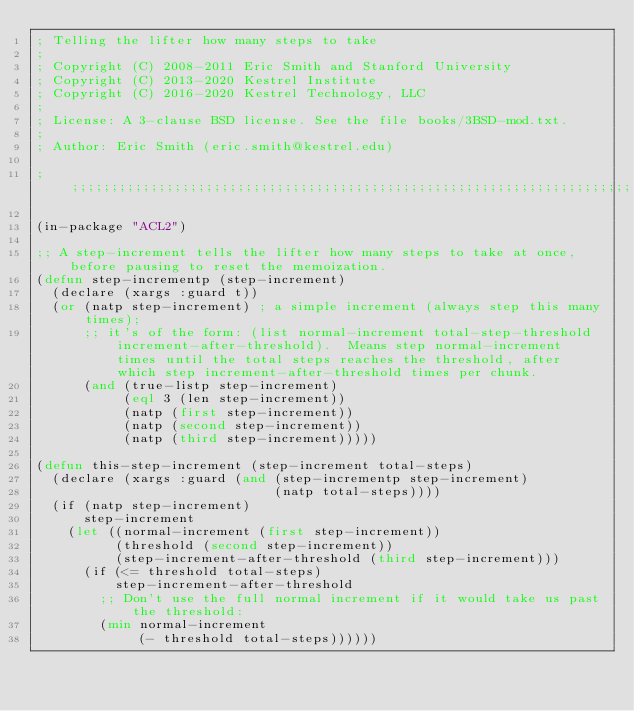<code> <loc_0><loc_0><loc_500><loc_500><_Lisp_>; Telling the lifter how many steps to take
;
; Copyright (C) 2008-2011 Eric Smith and Stanford University
; Copyright (C) 2013-2020 Kestrel Institute
; Copyright (C) 2016-2020 Kestrel Technology, LLC
;
; License: A 3-clause BSD license. See the file books/3BSD-mod.txt.
;
; Author: Eric Smith (eric.smith@kestrel.edu)

;;;;;;;;;;;;;;;;;;;;;;;;;;;;;;;;;;;;;;;;;;;;;;;;;;;;;;;;;;;;;;;;;;;;;;;;;;;;;;;;

(in-package "ACL2")

;; A step-increment tells the lifter how many steps to take at once, before pausing to reset the memoization.
(defun step-incrementp (step-increment)
  (declare (xargs :guard t))
  (or (natp step-increment) ; a simple increment (always step this many times);
      ;; it's of the form: (list normal-increment total-step-threshold increment-after-threshold).  Means step normal-increment times until the total steps reaches the threshold, after which step increment-after-threshold times per chunk.
      (and (true-listp step-increment)
           (eql 3 (len step-increment))
           (natp (first step-increment))
           (natp (second step-increment))
           (natp (third step-increment)))))

(defun this-step-increment (step-increment total-steps)
  (declare (xargs :guard (and (step-incrementp step-increment)
                              (natp total-steps))))
  (if (natp step-increment)
      step-increment
    (let ((normal-increment (first step-increment))
          (threshold (second step-increment))
          (step-increment-after-threshold (third step-increment)))
      (if (<= threshold total-steps)
          step-increment-after-threshold
        ;; Don't use the full normal increment if it would take us past the threshold:
        (min normal-increment
             (- threshold total-steps))))))
</code> 